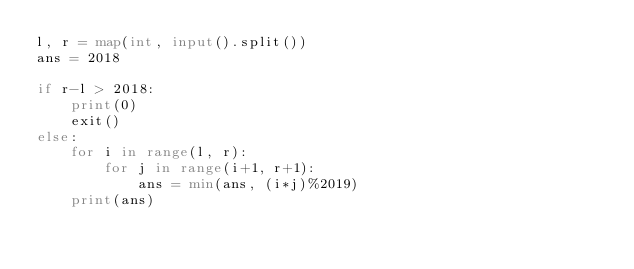Convert code to text. <code><loc_0><loc_0><loc_500><loc_500><_Python_>l, r = map(int, input().split())
ans = 2018

if r-l > 2018:
    print(0)
    exit()
else:
    for i in range(l, r):
        for j in range(i+1, r+1):
            ans = min(ans, (i*j)%2019)
    print(ans)</code> 